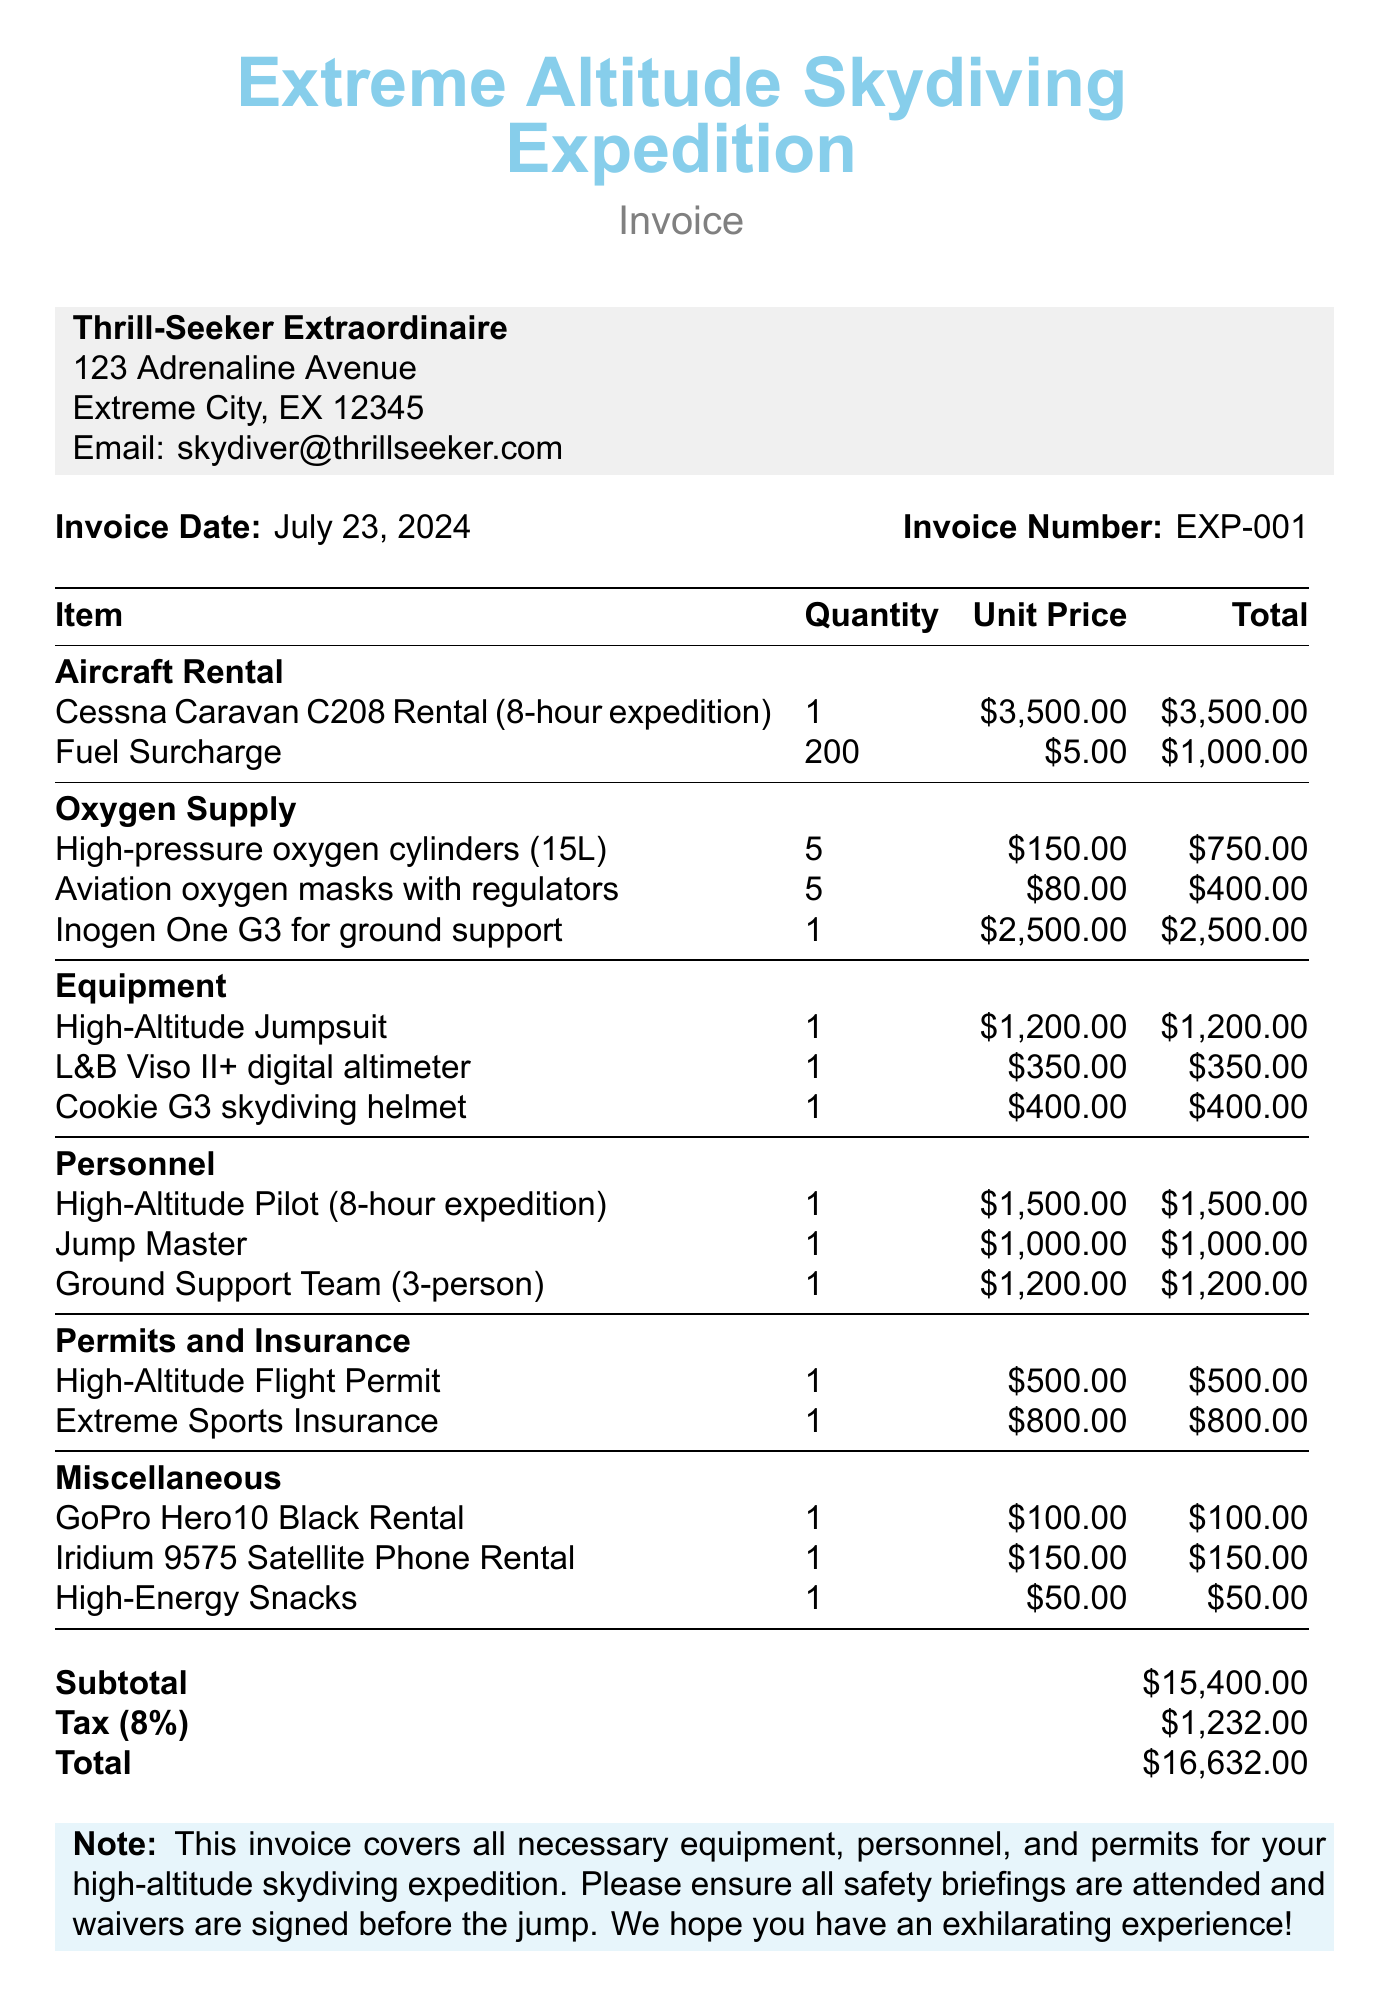What is the total amount due? The total amount due is the final amount calculated after tax, which is $16,632.
Answer: $16,632 How many oxygen cylinders are included? The document lists 5 oxygen cylinders in the oxygen supply section.
Answer: 5 What is the unit price for the Cessna Caravan C208 rental? The unit price for the Cessna Caravan C208 rental is specified as $3,500.
Answer: $3,500 Who is the high-altitude pilot? The document states that there is a high-altitude pilot included, but does not provide a specific name.
Answer: High-Altitude Pilot What is the tax rate applied to the invoice? The tax rate is indicated as 8%, calculated on the subtotal.
Answer: 8% What is the quantity of fuel surcharge charged? The quantity of fuel surcharge listed in the document is 200.
Answer: 200 What is the total for the Ground Support Team? The total for the Ground Support Team is calculated as $1,200 in the personnel section.
Answer: $1,200 What type of insurance is mentioned in the document? The document mentions "Extreme Sports Insurance" for coverage.
Answer: Extreme Sports Insurance What are the total charges for miscellaneous items? The total for miscellaneous items can be found by adding all miscellaneous costs, resulting in $300.
Answer: $300 